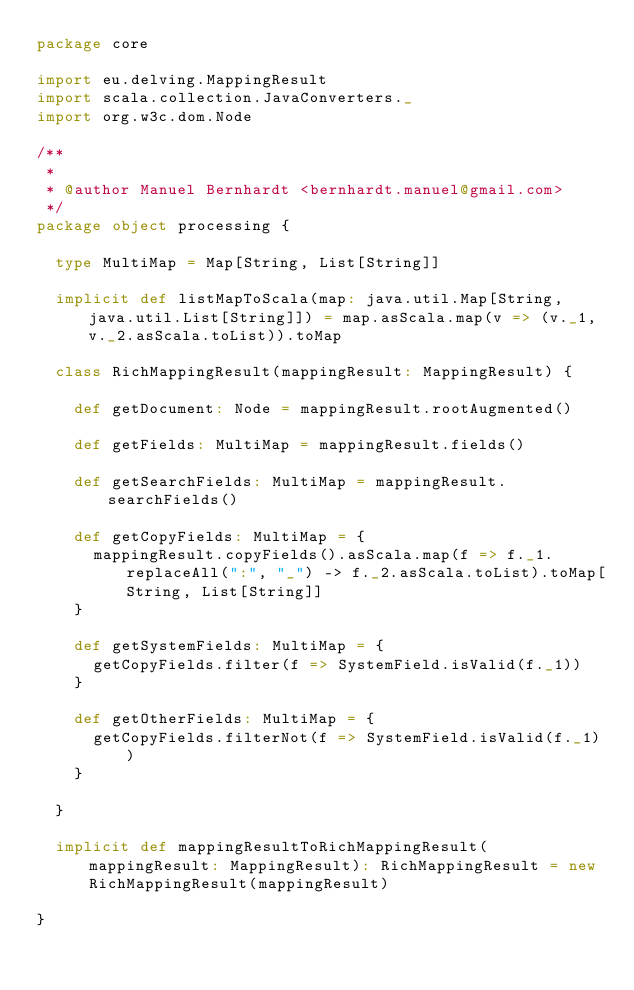<code> <loc_0><loc_0><loc_500><loc_500><_Scala_>package core

import eu.delving.MappingResult
import scala.collection.JavaConverters._
import org.w3c.dom.Node

/**
 *
 * @author Manuel Bernhardt <bernhardt.manuel@gmail.com>
 */
package object processing {

  type MultiMap = Map[String, List[String]]

  implicit def listMapToScala(map: java.util.Map[String, java.util.List[String]]) = map.asScala.map(v => (v._1, v._2.asScala.toList)).toMap

  class RichMappingResult(mappingResult: MappingResult) {

    def getDocument: Node = mappingResult.rootAugmented()

    def getFields: MultiMap = mappingResult.fields()

    def getSearchFields: MultiMap = mappingResult.searchFields()

    def getCopyFields: MultiMap = {
      mappingResult.copyFields().asScala.map(f => f._1.replaceAll(":", "_") -> f._2.asScala.toList).toMap[String, List[String]]
    }

    def getSystemFields: MultiMap = {
      getCopyFields.filter(f => SystemField.isValid(f._1))
    }

    def getOtherFields: MultiMap = {
      getCopyFields.filterNot(f => SystemField.isValid(f._1))
    }

  }

  implicit def mappingResultToRichMappingResult(mappingResult: MappingResult): RichMappingResult = new RichMappingResult(mappingResult)

}
</code> 